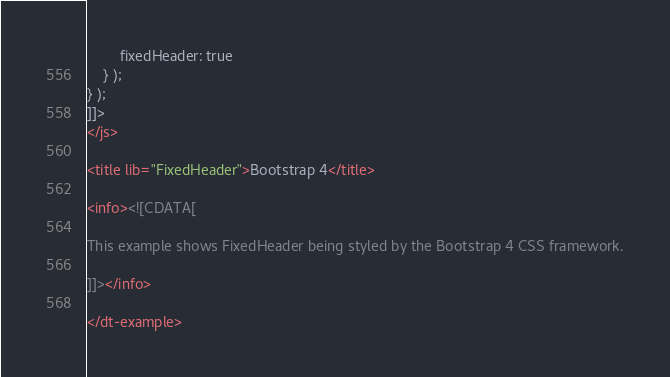Convert code to text. <code><loc_0><loc_0><loc_500><loc_500><_XML_>		fixedHeader: true
	} );
} );
]]>
</js>

<title lib="FixedHeader">Bootstrap 4</title>

<info><![CDATA[

This example shows FixedHeader being styled by the Bootstrap 4 CSS framework.

]]></info>

</dt-example>
</code> 